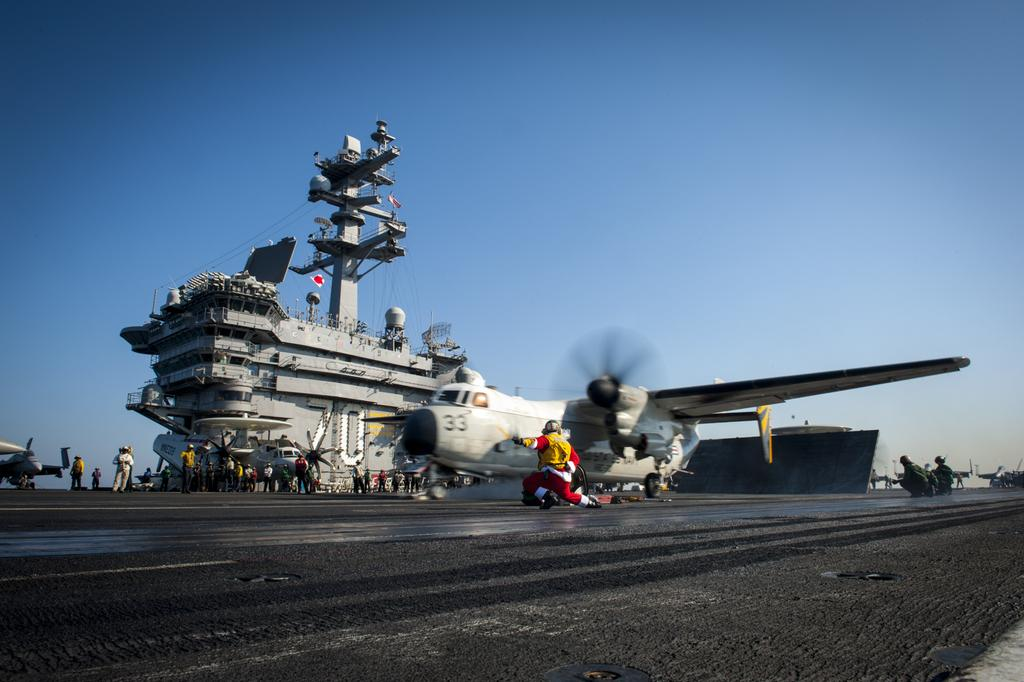What is the main subject of the image? The main subject of the image is an airplane. Where is the airplane located in the image? The airplane is on a runway. What is happening in front of the airplane? There is a person running in front of the airplane. What other mode of transportation can be seen in the image? There is a ship in the image. What are the people near the ship doing? There are people standing in front of the ship. What is visible in the background of the image? The sky is visible in the image. How many dogs are playing with the cable in the image? There are no dogs or cables present in the image. What type of vacation is the person taking in the image? There is no indication of a vacation in the image; it simply shows an airplane on a runway and a ship with people nearby. 